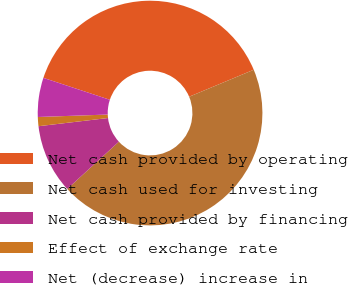Convert chart to OTSL. <chart><loc_0><loc_0><loc_500><loc_500><pie_chart><fcel>Net cash provided by operating<fcel>Net cash used for investing<fcel>Net cash provided by financing<fcel>Effect of exchange rate<fcel>Net (decrease) increase in<nl><fcel>38.63%<fcel>44.49%<fcel>9.94%<fcel>1.31%<fcel>5.63%<nl></chart> 